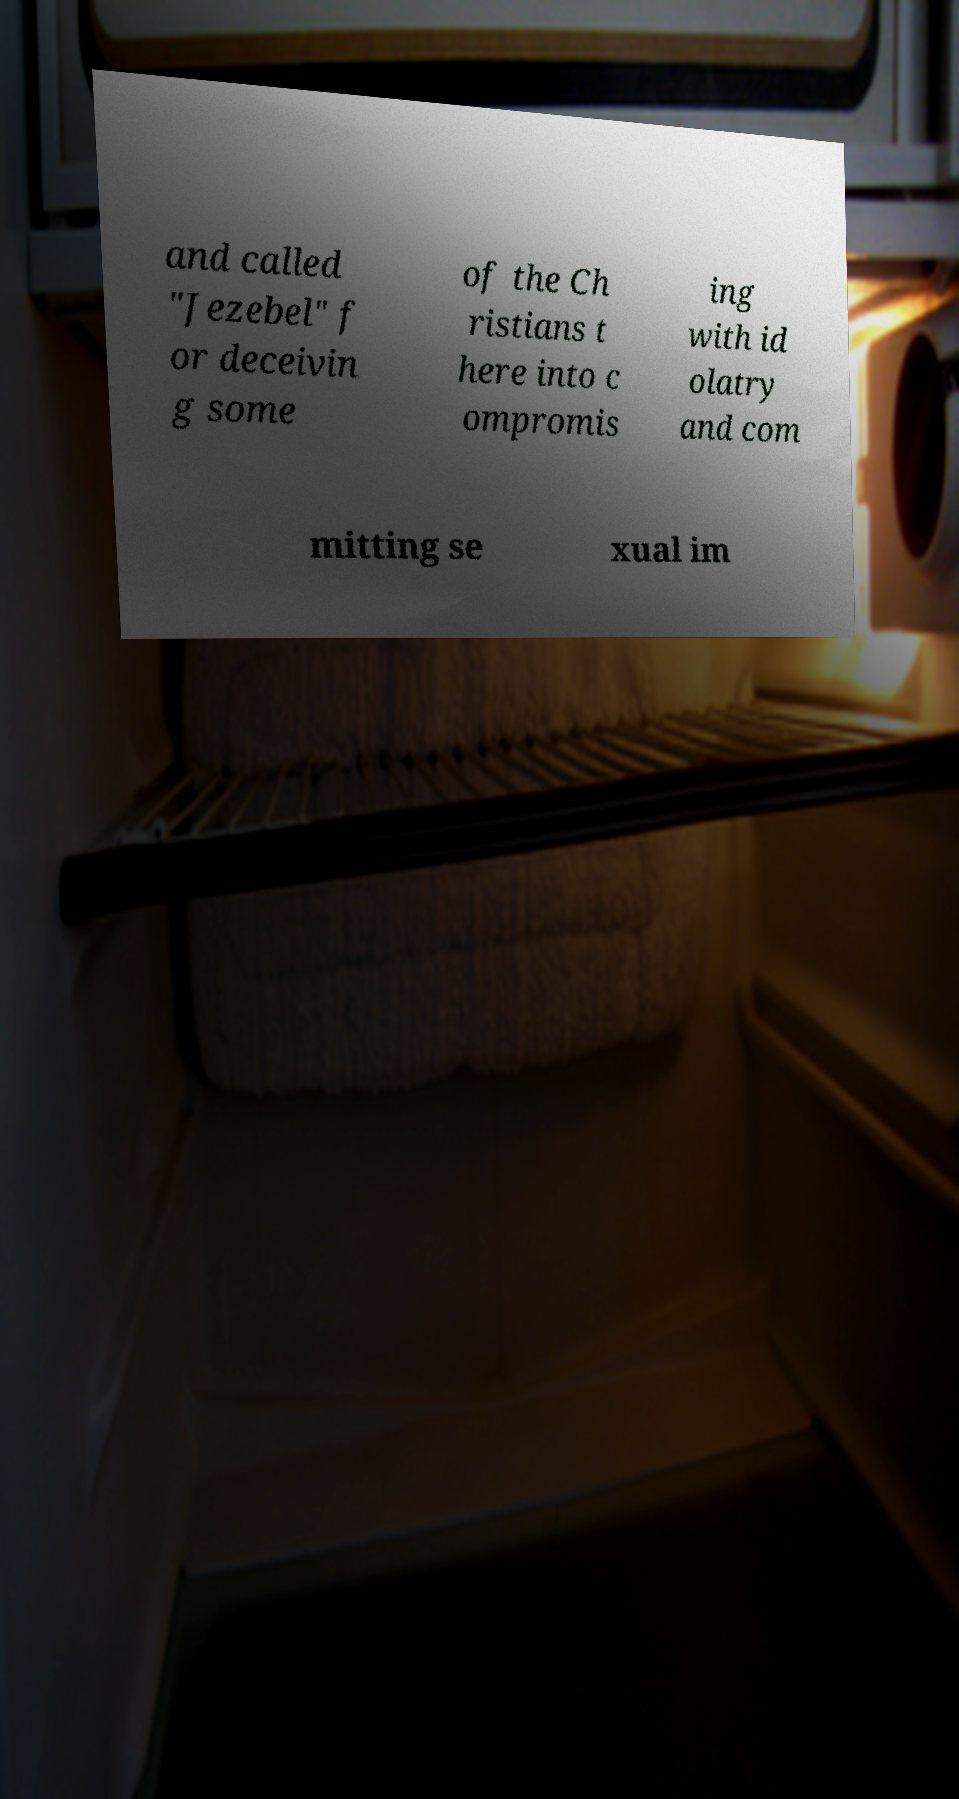Can you accurately transcribe the text from the provided image for me? and called "Jezebel" f or deceivin g some of the Ch ristians t here into c ompromis ing with id olatry and com mitting se xual im 